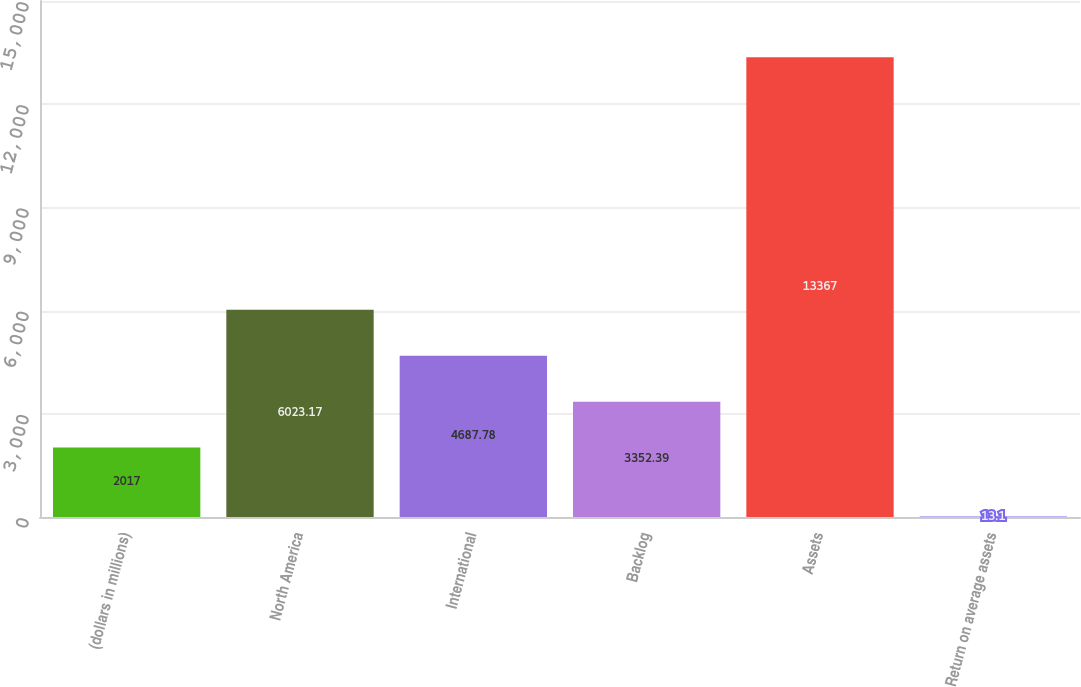<chart> <loc_0><loc_0><loc_500><loc_500><bar_chart><fcel>(dollars in millions)<fcel>North America<fcel>International<fcel>Backlog<fcel>Assets<fcel>Return on average assets<nl><fcel>2017<fcel>6023.17<fcel>4687.78<fcel>3352.39<fcel>13367<fcel>13.1<nl></chart> 